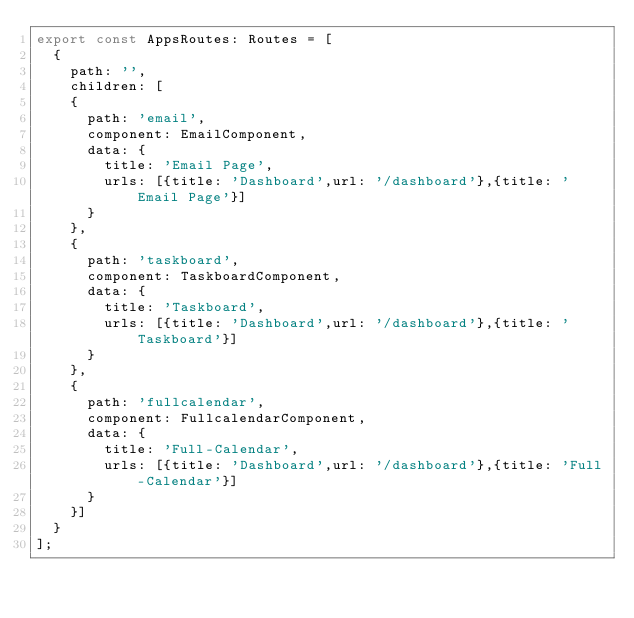Convert code to text. <code><loc_0><loc_0><loc_500><loc_500><_TypeScript_>export const AppsRoutes: Routes = [
  {
    path: '',
    children: [
    {
      path: 'email',
      component: EmailComponent,
      data: {
        title: 'Email Page',
        urls: [{title: 'Dashboard',url: '/dashboard'},{title: 'Email Page'}]
      }
    },
    {
      path: 'taskboard',
      component: TaskboardComponent,
      data: {
        title: 'Taskboard',
        urls: [{title: 'Dashboard',url: '/dashboard'},{title: 'Taskboard'}]
      }
    },
    {
      path: 'fullcalendar',
      component: FullcalendarComponent,
      data: {
        title: 'Full-Calendar',
        urls: [{title: 'Dashboard',url: '/dashboard'},{title: 'Full-Calendar'}]
      }
    }]
  }
];
</code> 